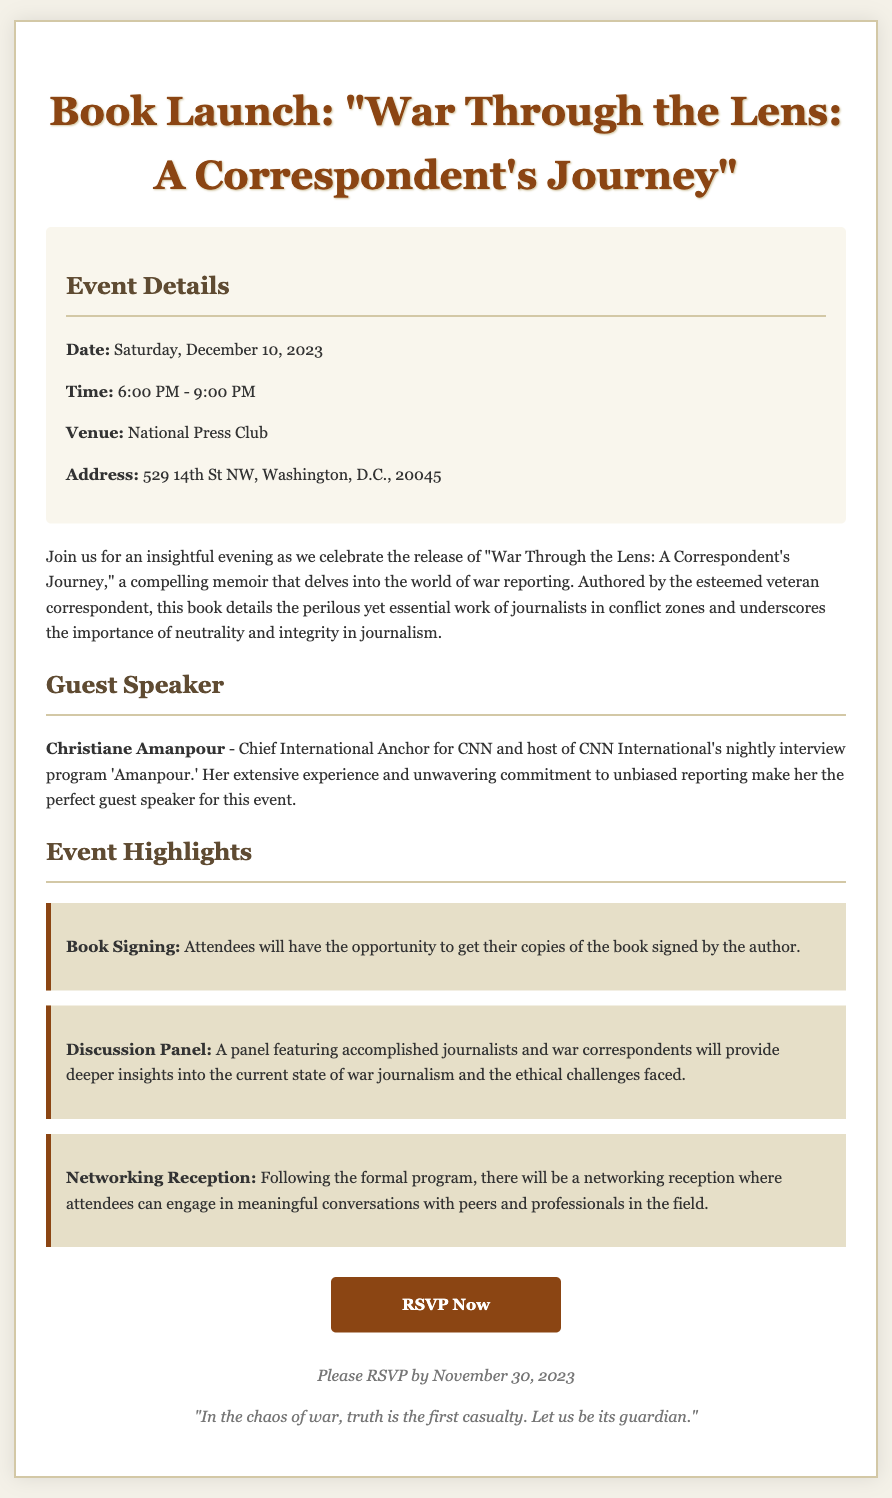What is the date of the event? The document specifies that the event will take place on Saturday, December 10, 2023.
Answer: December 10, 2023 Who is the guest speaker? According to the RSVP card, the guest speaker is Christiane Amanpour.
Answer: Christiane Amanpour What time does the event start? The document states that the event will start at 6:00 PM.
Answer: 6:00 PM What is the location of the venue? The RSVP mentions the venue as the National Press Club located at 529 14th St NW, Washington, D.C., 20045.
Answer: National Press Club When is the RSVP deadline? The document indicates that RSVPs should be submitted by November 30, 2023.
Answer: November 30, 2023 What is included in the event highlights? The outlined highlights include a Book Signing, a Discussion Panel, and a Networking Reception.
Answer: Book Signing, Discussion Panel, Networking Reception Why is neutrality emphasized in the event description? The event reflects on the ethical challenges in journalism, emphasizing the importance of neutrality and integrity.
Answer: Importance of neutrality and integrity What is the purpose of the networking reception? The networking reception aims to provide attendees the chance to engage in conversations with peers and professionals.
Answer: Engage in meaningful conversations What style of event is this document announcing? The RSVP card announces a book launch event featuring a discussion and signing.
Answer: Book launch event 